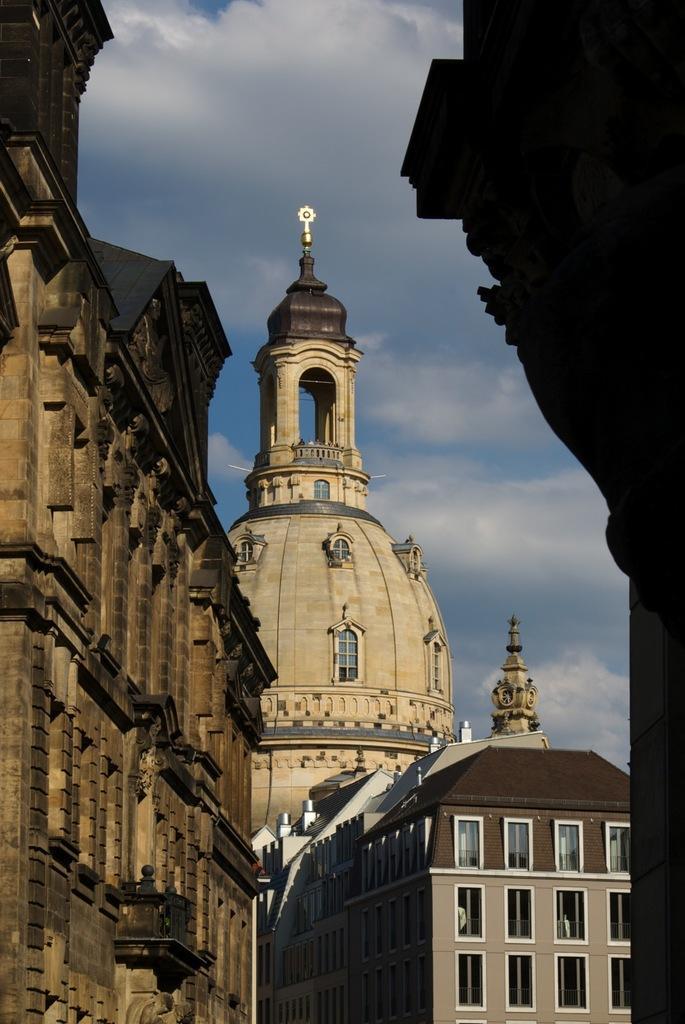Please provide a concise description of this image. In this image we can see some buildings with windows. We can also see the sky which looks cloudy. 